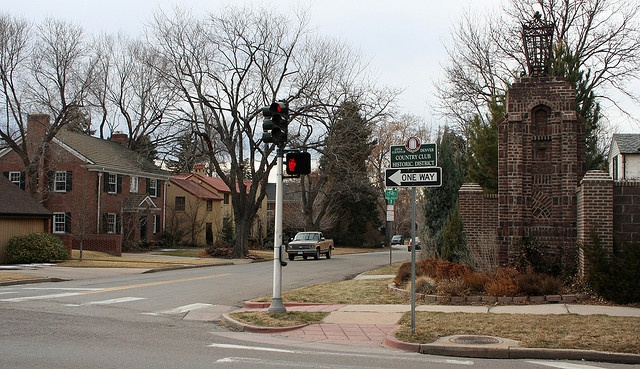Describe the objects in this image and their specific colors. I can see truck in lavender, black, gray, and darkgray tones, traffic light in lavender, black, gray, maroon, and darkgray tones, traffic light in lavender, black, brown, and gray tones, traffic light in lavender, black, gray, darkgray, and lightgray tones, and car in lavender, black, gray, and darkgray tones in this image. 